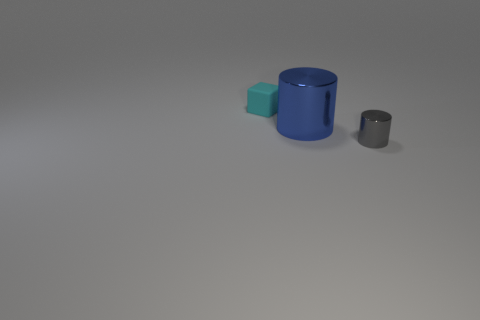Add 1 large yellow rubber balls. How many objects exist? 4 Subtract all cylinders. How many objects are left? 1 Subtract all green rubber objects. Subtract all big blue cylinders. How many objects are left? 2 Add 2 cyan cubes. How many cyan cubes are left? 3 Add 2 large blue rubber things. How many large blue rubber things exist? 2 Subtract 1 gray cylinders. How many objects are left? 2 